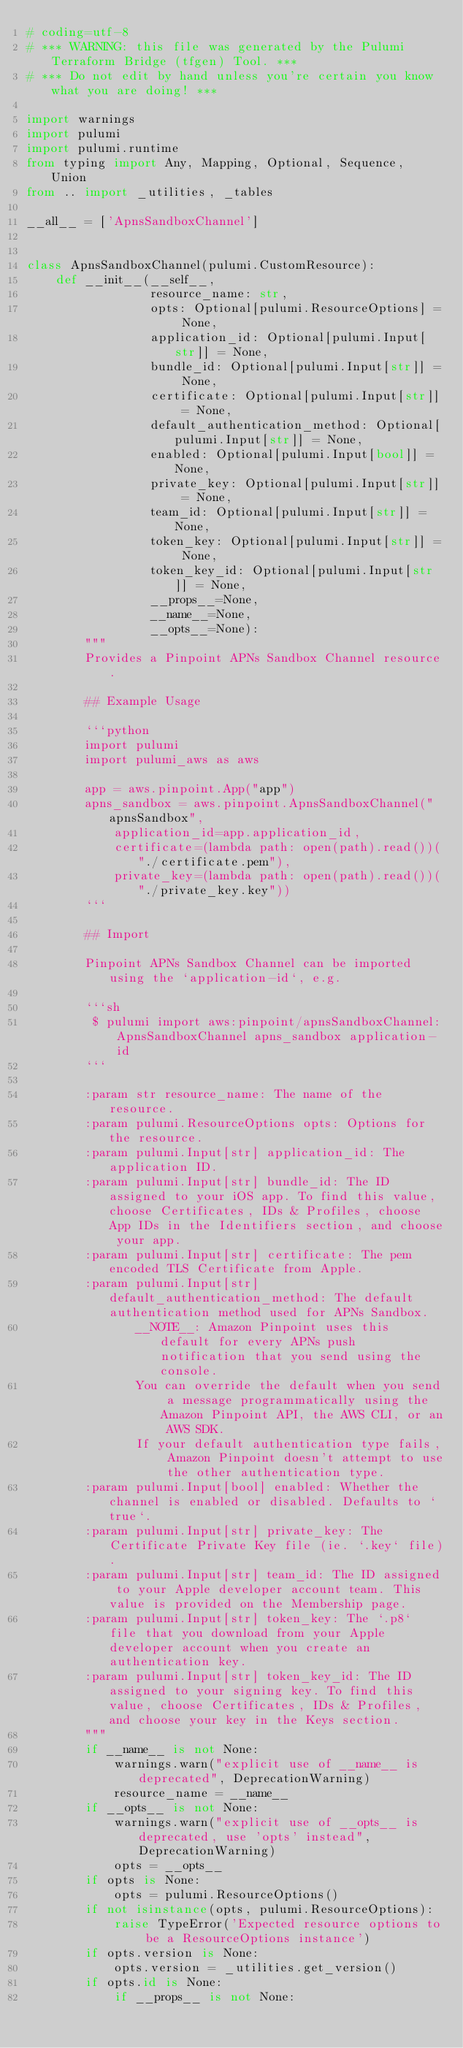Convert code to text. <code><loc_0><loc_0><loc_500><loc_500><_Python_># coding=utf-8
# *** WARNING: this file was generated by the Pulumi Terraform Bridge (tfgen) Tool. ***
# *** Do not edit by hand unless you're certain you know what you are doing! ***

import warnings
import pulumi
import pulumi.runtime
from typing import Any, Mapping, Optional, Sequence, Union
from .. import _utilities, _tables

__all__ = ['ApnsSandboxChannel']


class ApnsSandboxChannel(pulumi.CustomResource):
    def __init__(__self__,
                 resource_name: str,
                 opts: Optional[pulumi.ResourceOptions] = None,
                 application_id: Optional[pulumi.Input[str]] = None,
                 bundle_id: Optional[pulumi.Input[str]] = None,
                 certificate: Optional[pulumi.Input[str]] = None,
                 default_authentication_method: Optional[pulumi.Input[str]] = None,
                 enabled: Optional[pulumi.Input[bool]] = None,
                 private_key: Optional[pulumi.Input[str]] = None,
                 team_id: Optional[pulumi.Input[str]] = None,
                 token_key: Optional[pulumi.Input[str]] = None,
                 token_key_id: Optional[pulumi.Input[str]] = None,
                 __props__=None,
                 __name__=None,
                 __opts__=None):
        """
        Provides a Pinpoint APNs Sandbox Channel resource.

        ## Example Usage

        ```python
        import pulumi
        import pulumi_aws as aws

        app = aws.pinpoint.App("app")
        apns_sandbox = aws.pinpoint.ApnsSandboxChannel("apnsSandbox",
            application_id=app.application_id,
            certificate=(lambda path: open(path).read())("./certificate.pem"),
            private_key=(lambda path: open(path).read())("./private_key.key"))
        ```

        ## Import

        Pinpoint APNs Sandbox Channel can be imported using the `application-id`, e.g.

        ```sh
         $ pulumi import aws:pinpoint/apnsSandboxChannel:ApnsSandboxChannel apns_sandbox application-id
        ```

        :param str resource_name: The name of the resource.
        :param pulumi.ResourceOptions opts: Options for the resource.
        :param pulumi.Input[str] application_id: The application ID.
        :param pulumi.Input[str] bundle_id: The ID assigned to your iOS app. To find this value, choose Certificates, IDs & Profiles, choose App IDs in the Identifiers section, and choose your app.
        :param pulumi.Input[str] certificate: The pem encoded TLS Certificate from Apple.
        :param pulumi.Input[str] default_authentication_method: The default authentication method used for APNs Sandbox.
               __NOTE__: Amazon Pinpoint uses this default for every APNs push notification that you send using the console.
               You can override the default when you send a message programmatically using the Amazon Pinpoint API, the AWS CLI, or an AWS SDK.
               If your default authentication type fails, Amazon Pinpoint doesn't attempt to use the other authentication type.
        :param pulumi.Input[bool] enabled: Whether the channel is enabled or disabled. Defaults to `true`.
        :param pulumi.Input[str] private_key: The Certificate Private Key file (ie. `.key` file).
        :param pulumi.Input[str] team_id: The ID assigned to your Apple developer account team. This value is provided on the Membership page.
        :param pulumi.Input[str] token_key: The `.p8` file that you download from your Apple developer account when you create an authentication key.
        :param pulumi.Input[str] token_key_id: The ID assigned to your signing key. To find this value, choose Certificates, IDs & Profiles, and choose your key in the Keys section.
        """
        if __name__ is not None:
            warnings.warn("explicit use of __name__ is deprecated", DeprecationWarning)
            resource_name = __name__
        if __opts__ is not None:
            warnings.warn("explicit use of __opts__ is deprecated, use 'opts' instead", DeprecationWarning)
            opts = __opts__
        if opts is None:
            opts = pulumi.ResourceOptions()
        if not isinstance(opts, pulumi.ResourceOptions):
            raise TypeError('Expected resource options to be a ResourceOptions instance')
        if opts.version is None:
            opts.version = _utilities.get_version()
        if opts.id is None:
            if __props__ is not None:</code> 